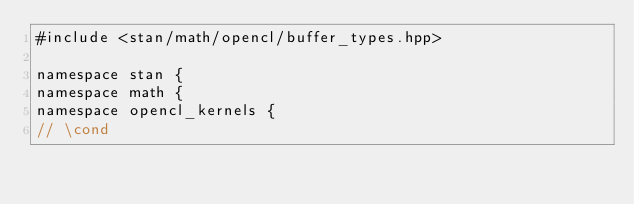<code> <loc_0><loc_0><loc_500><loc_500><_C++_>#include <stan/math/opencl/buffer_types.hpp>

namespace stan {
namespace math {
namespace opencl_kernels {
// \cond</code> 